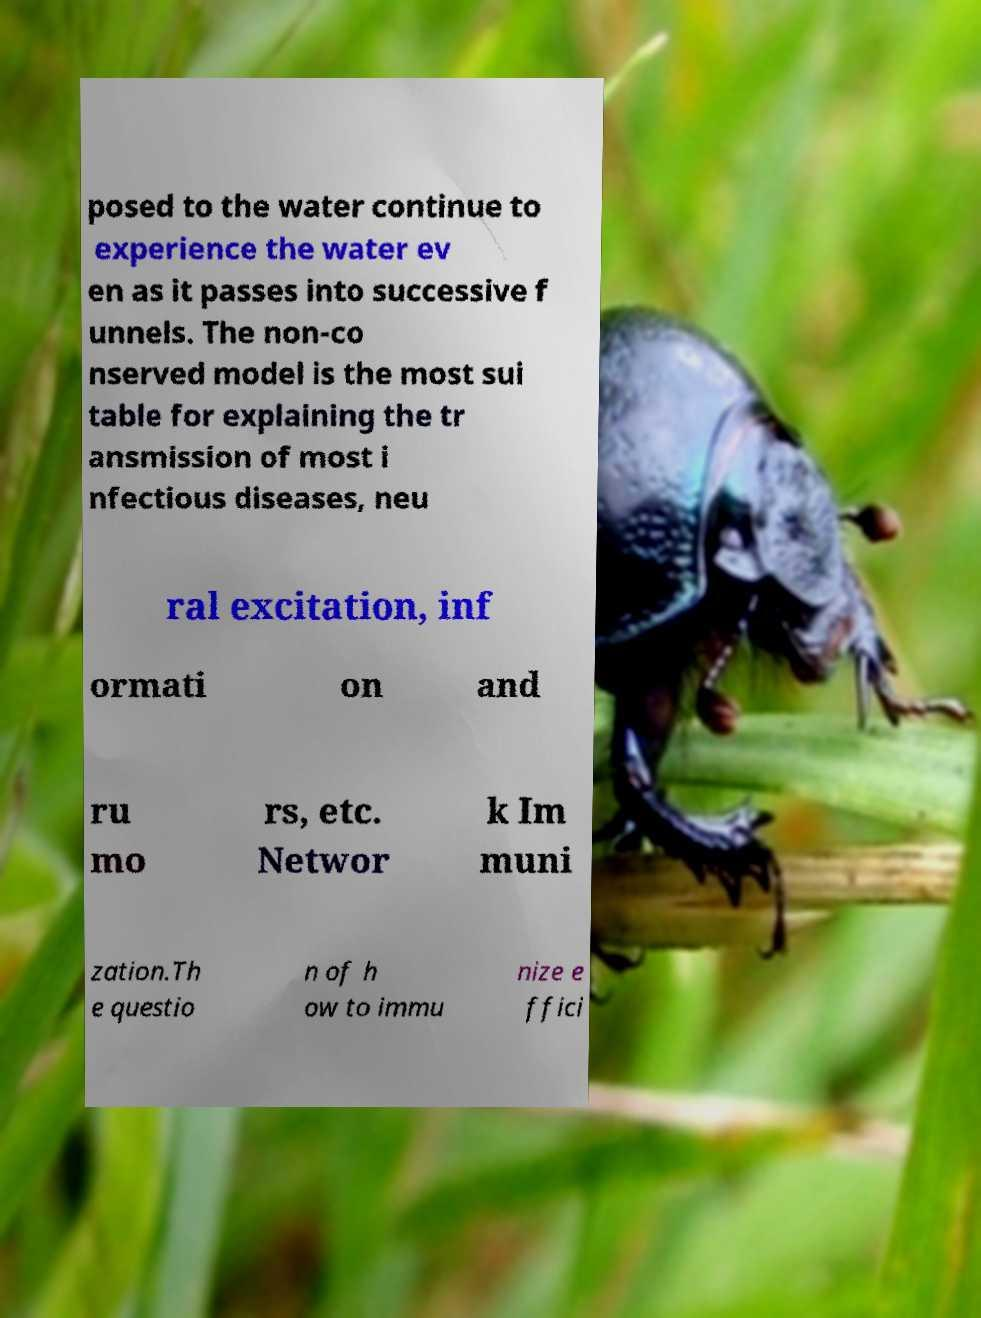Could you extract and type out the text from this image? posed to the water continue to experience the water ev en as it passes into successive f unnels. The non-co nserved model is the most sui table for explaining the tr ansmission of most i nfectious diseases, neu ral excitation, inf ormati on and ru mo rs, etc. Networ k Im muni zation.Th e questio n of h ow to immu nize e ffici 